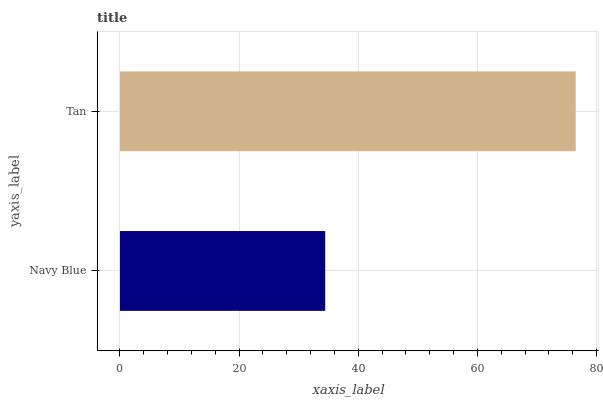Is Navy Blue the minimum?
Answer yes or no. Yes. Is Tan the maximum?
Answer yes or no. Yes. Is Tan the minimum?
Answer yes or no. No. Is Tan greater than Navy Blue?
Answer yes or no. Yes. Is Navy Blue less than Tan?
Answer yes or no. Yes. Is Navy Blue greater than Tan?
Answer yes or no. No. Is Tan less than Navy Blue?
Answer yes or no. No. Is Tan the high median?
Answer yes or no. Yes. Is Navy Blue the low median?
Answer yes or no. Yes. Is Navy Blue the high median?
Answer yes or no. No. Is Tan the low median?
Answer yes or no. No. 